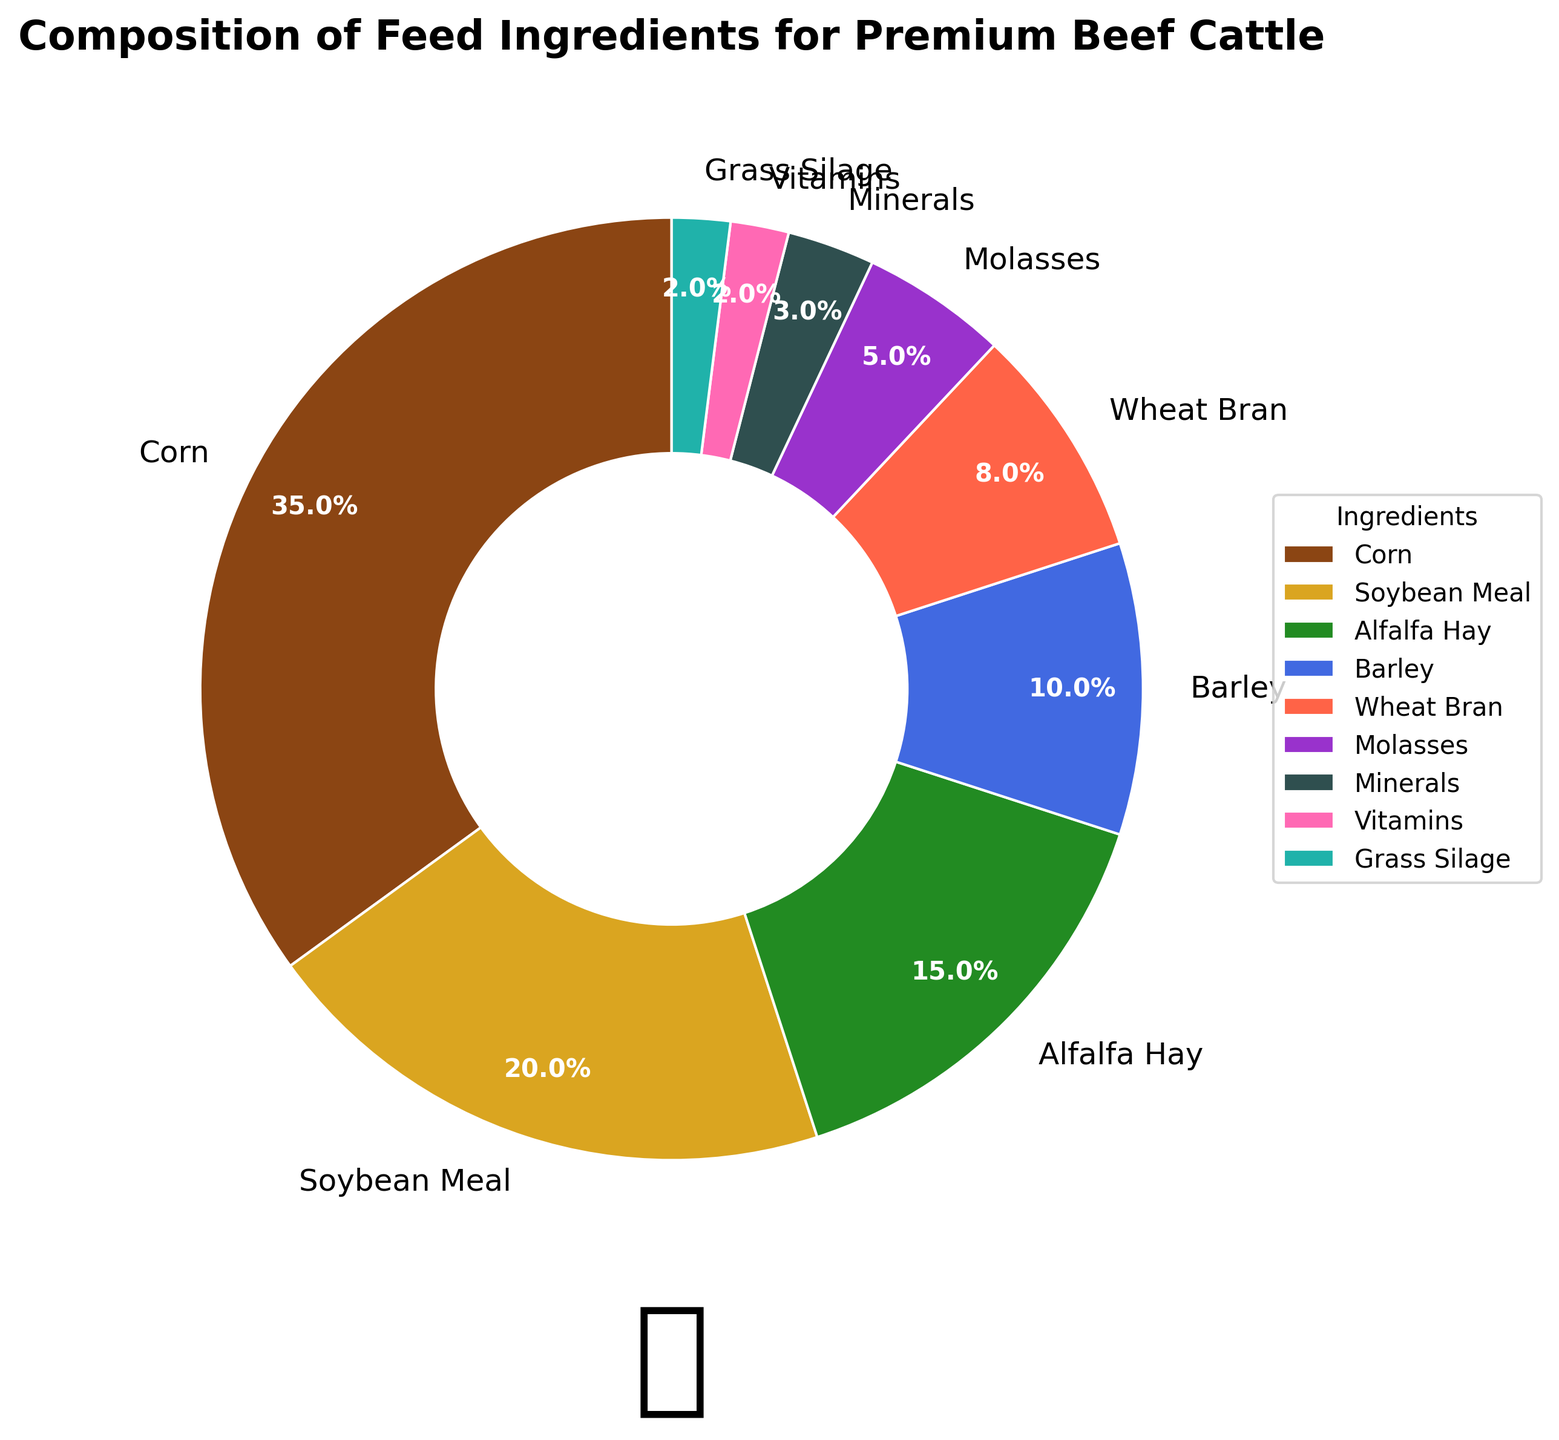What percentage of the feed ingredients is comprised of minerals, vitamins, and grass silage combined? To find this, sum the percentage values of minerals (3%), vitamins (2%), and grass silage (2%): 3 + 2 + 2 = 7
Answer: 7% Which ingredient category has the highest percentage in the feed composition? By looking at the pie chart, the largest segment represents the ingredient with the highest percentage, which is labeled as corn at 35%.
Answer: Corn How much larger is the percentage of soybean meal compared to barley? Subtract the percentage of barley (10%) from the percentage of soybean meal (20%): 20 - 10 = 10
Answer: 10% What is the total percentage of the three largest feed ingredients? The three largest feed ingredients by percentage are corn (35%), soybean meal (20%), and alfalfa hay (15%). Summing these gives us: 35 + 20 + 15 = 70
Answer: 70% If you combine the percentages of barley and wheat bran, would they surpass the percentage of alfalfa hay? First, find the sum of the percentages of barley (10%) and wheat bran (8%): 10 + 8 = 18. Then compare it with the percentage of alfalfa hay (15%) and see that 18% is greater than 15%
Answer: Yes Which ingredient has the smallest contribution to the feed composition, and what is its percentage? The smallest segment in the pie chart corresponds to vitamins at 2%.
Answer: Vitamins, 2% Are the percentages of molasses and minerals combined greater than the percentage of barley? Sum the percentages of molasses (5%) and minerals (3%) to get: 5 + 3 = 8. Then compare this with the percentage of barley (10%) to see that 8% is less than 10%
Answer: No How do the proportions of molasses and grass silage compare? By looking at the pie chart, molasses represents 5% while grass silage represents 2%. Hence, molasses is more than double the percentage of grass silage
Answer: Molasses is larger by 3% 